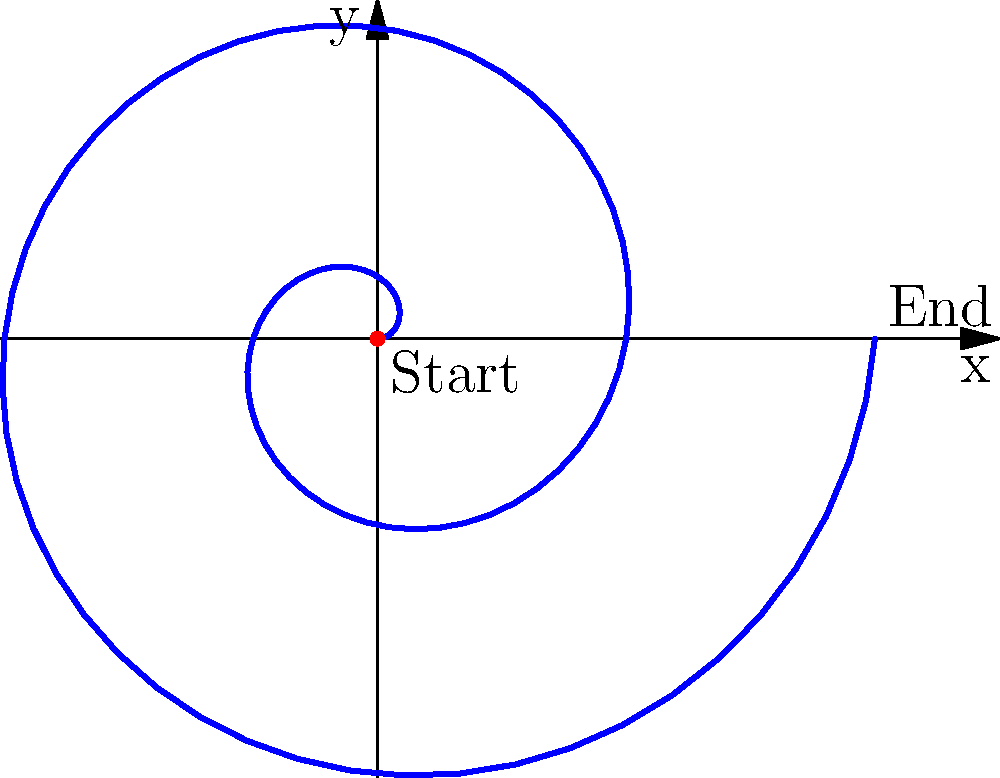In your novel about a cattle ranch, you want to describe the spiral movement pattern of cattle during a roundup. If the cattle's path can be modeled by the polar equation $r = 0.5\theta$, where $r$ is in miles and $\theta$ is in radians, what is the total distance traveled by the cattle after two complete revolutions? To solve this problem, we need to follow these steps:

1) First, we need to understand that two complete revolutions mean $\theta$ goes from 0 to $4\pi$ radians.

2) The length of a curve in polar coordinates is given by the formula:

   $$L = \int_a^b \sqrt{r^2 + \left(\frac{dr}{d\theta}\right)^2} d\theta$$

3) In our case, $r = 0.5\theta$, so $\frac{dr}{d\theta} = 0.5$

4) Substituting these into the formula:

   $$L = \int_0^{4\pi} \sqrt{(0.5\theta)^2 + (0.5)^2} d\theta$$

5) Simplify under the square root:

   $$L = \int_0^{4\pi} \sqrt{0.25\theta^2 + 0.25} d\theta$$

6) Factor out 0.25:

   $$L = 0.5 \int_0^{4\pi} \sqrt{\theta^2 + 1} d\theta$$

7) This integral doesn't have an elementary antiderivative. We need to use the hyperbolic functions:

   $$L = 0.5 \left[\frac{\theta}{2}\sqrt{\theta^2+1} + \frac{1}{2}\ln(\theta + \sqrt{\theta^2+1})\right]_0^{4\pi}$$

8) Evaluate at the limits:

   $$L = 0.5 \left[\frac{4\pi}{2}\sqrt{(4\pi)^2+1} + \frac{1}{2}\ln(4\pi + \sqrt{(4\pi)^2+1}) - 0\right]$$

9) Simplify:

   $$L \approx 12.57 \text{ miles}$$
Answer: 12.57 miles 